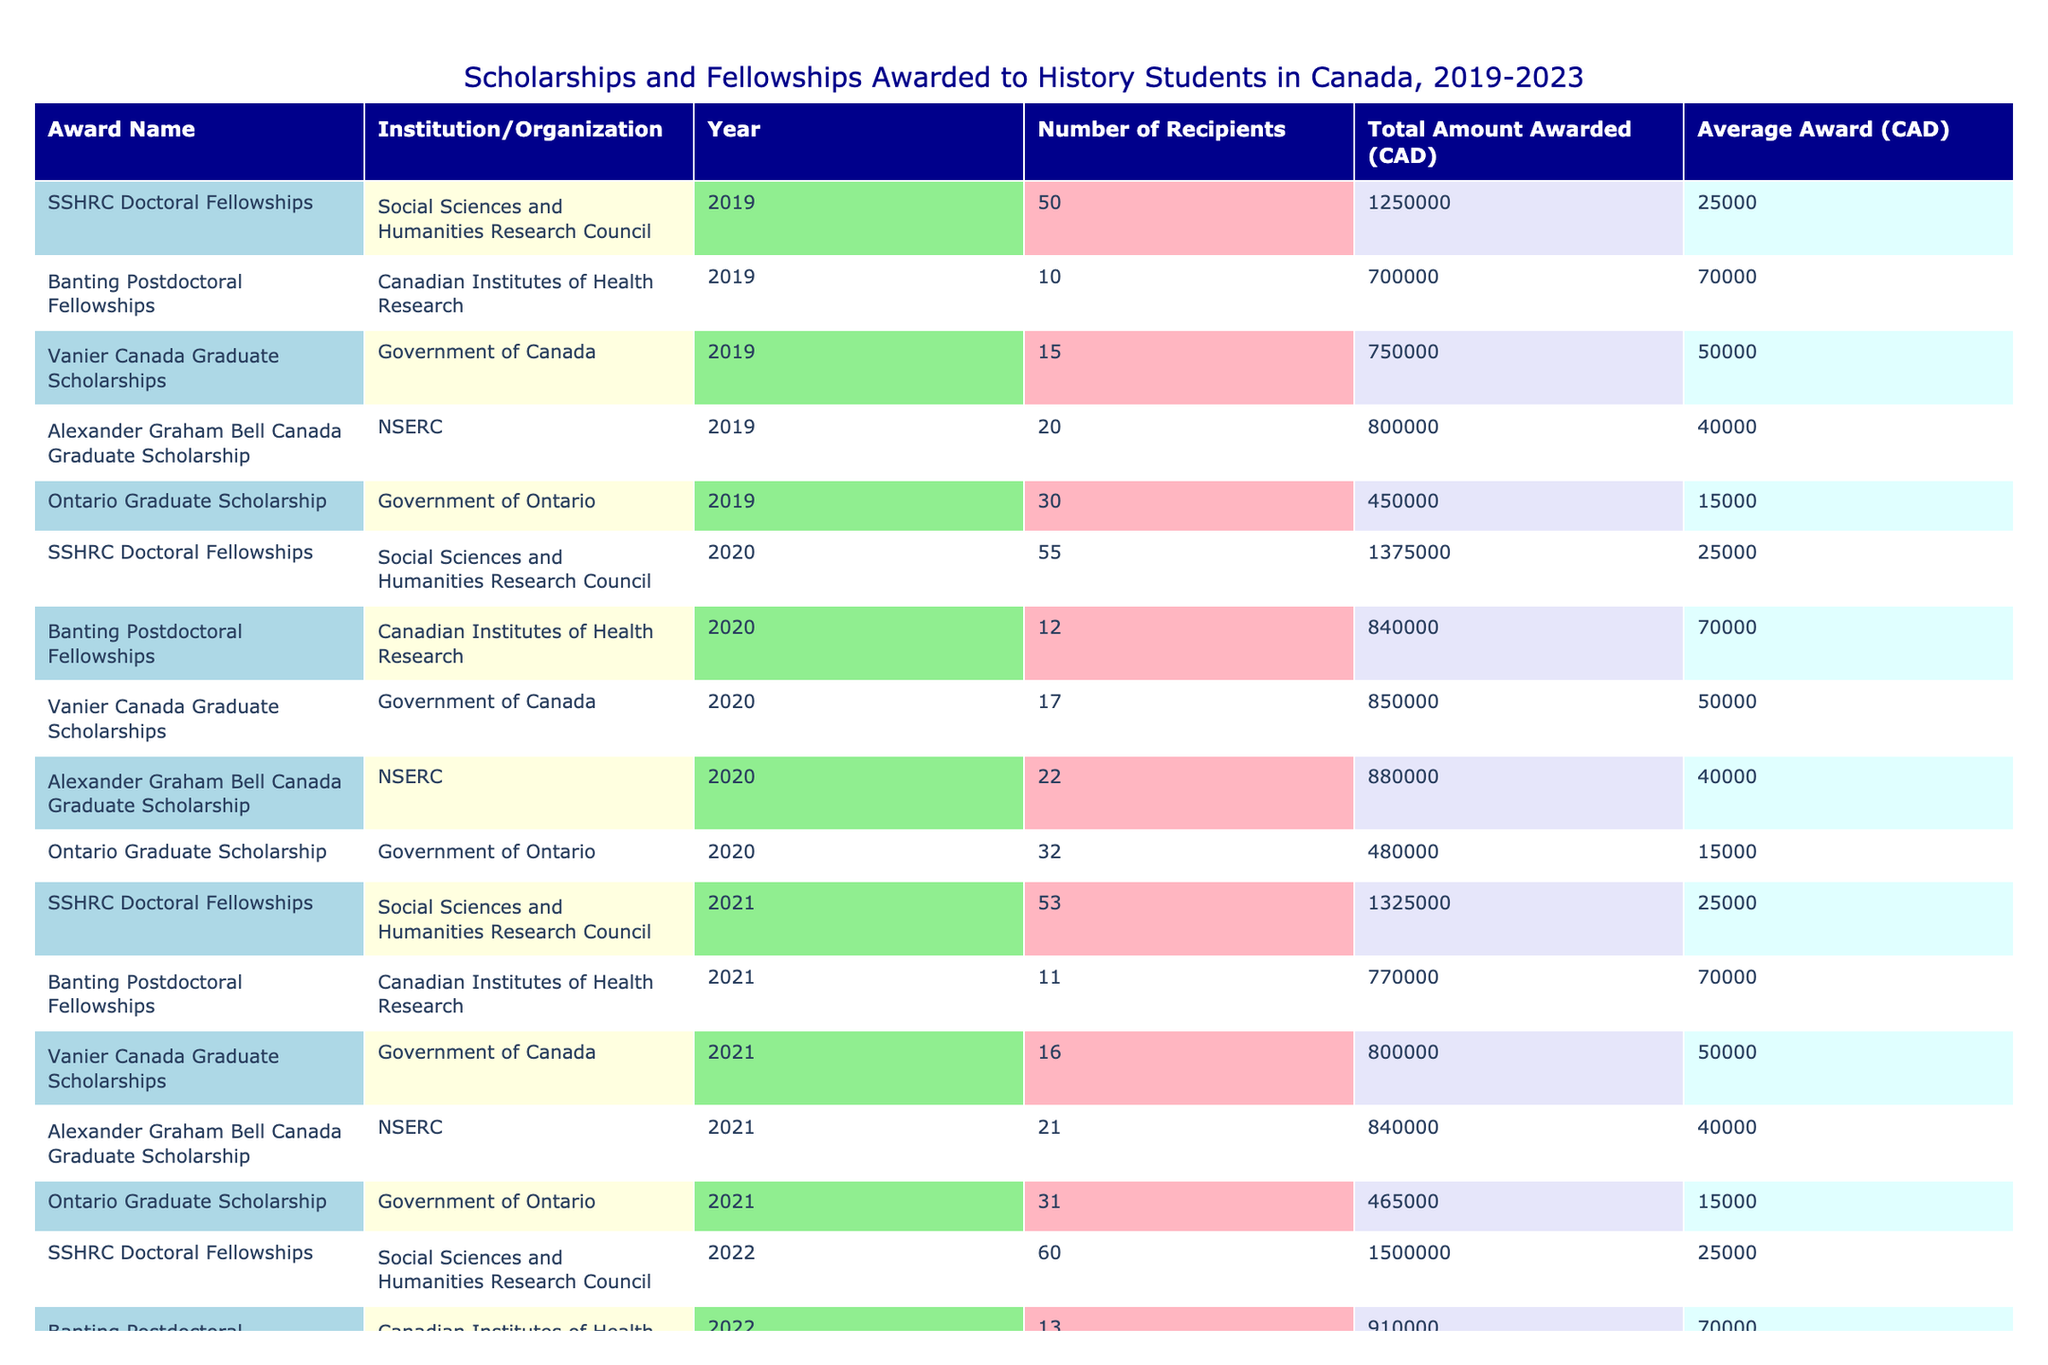What was the total amount awarded for SSHRC Doctoral Fellowships in 2020? From the table, we look for the row where the Award Name is "SSHRC Doctoral Fellowships" and the Year is 2020. The Total Amount Awarded for that entry is listed as 1,375,000 CAD.
Answer: 1,375,000 CAD In what year did Ontario Graduate Scholarship have the highest number of recipients? By examining the "Number of Recipients" column for the Ontario Graduate Scholarship, we see values for each year: 30 in 2019, 32 in 2020, 31 in 2021, 34 in 2022, and 35 in 2023. The highest number of recipients is 35 in 2023.
Answer: 2023 How much total funding was awarded through Banting Postdoctoral Fellowships from 2019 to 2023? We sum the Total Amount Awarded for Banting Postdoctoral Fellowships for each year: 700,000 (2019) + 840,000 (2020) + 770,000 (2021) + 910,000 (2022) + 980,000 (2023) = 4,200,000 CAD.
Answer: 4,200,000 CAD Did the total amount awarded for Vanier Canada Graduate Scholarships increase every year? We can compare the Total Amount Awarded for Vanier Canada Graduate Scholarships across the years: 750,000 (2019), 850,000 (2020), 800,000 (2021), 900,000 (2022), 950,000 (2023). The amount decreased from 2020 to 2021, so the answer is no.
Answer: No What was the average award for Alexander Graham Bell Canada Graduate Scholarship in 2022? The Total Amount Awarded for this scholarship in 2022 is 920,000 CAD, and the number of recipients is 23. To find the average, we calculate 920,000 CAD divided by 23, which equals approximately 40,000 CAD. This value rounds to 40,000 CAD.
Answer: 40,000 CAD Which scholarship had the largest average award in the year 2021, and what was the amount? We first find the average awards for each scholarship in 2021: SSHRC Doctoral Fellowships is approximately 25,000 CAD (1,325,000/53), Banting Postdoctoral Fellowships is about 70,000 CAD (770,000/11), Vanier Canada Graduate Scholarships is 50,000 CAD (800,000/16), Alexander Graham Bell is approximately 40,000 CAD (840,000/21), and Ontario Graduate Scholarship is about 15,000 CAD (465,000/31). The largest average was 25,000 CAD for SSHRC Doctoral Fellowships.
Answer: SSHRC Doctoral Fellowships, 25,000 CAD How many more recipients were there in SSHRC Doctoral Fellowships in 2022 compared to 2019? The number of recipients in 2019 was 50, and in 2022 it was 60. The difference is calculated as 60 - 50 = 10.
Answer: 10 Is the total amount awarded for Ontario Graduate Scholarships more than 2 million CAD from 2019 to 2023? Summing the amounts gives us: 450,000 (2019) + 480,000 (2020) + 465,000 (2021) + 510,000 (2022) + 525,000 (2023) = 2,430,000 CAD. Since this total exceeds 2 million CAD, the answer is yes.
Answer: Yes 